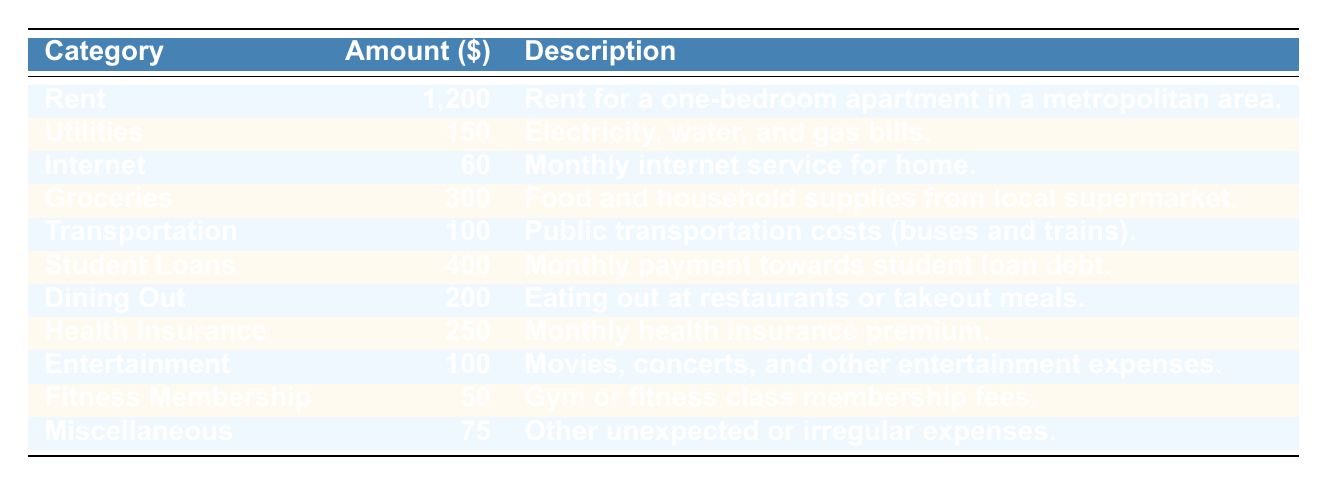What is the highest monthly expense category? Looking at the table, the category with the highest amount is "Rent," which totals 1,200.
Answer: Rent How much do recent graduates spend on utilities each month? The table lists "Utilities" as 150, indicating that is the monthly expense amount.
Answer: 150 What is the total expense on groceries and dining out combined? Adding the amounts for "Groceries" (300) and "Dining Out" (200) gives a total of 300 + 200 = 500.
Answer: 500 Is the amount spent on internet more than the amount spent on transportation? The amount for "Internet" is 60, and for "Transportation," it is 100. Since 60 is less than 100, the answer is no.
Answer: No What is the total monthly expenditure on health-related categories (health insurance and fitness membership)? The health-related categories are "Health Insurance" at 250 and "Fitness Membership" at 50. Adding these gives 250 + 50 = 300 as the total monthly expenditure.
Answer: 300 What percentage of the total monthly expenses is spent on student loans? Total monthly expenses sum up to 1,200 + 150 + 60 + 300 + 100 + 400 + 200 + 250 + 100 + 50 + 75 = 2,685. The amount for "Student Loans" is 400. To find the percentage, we calculate (400 / 2685) * 100, which is approximately 14.89%.
Answer: 14.89% Which two expenses are the least when combined? The two smallest amounts are "Fitness Membership" at 50 and "Miscellaneous" at 75. Adding them together gives 50 + 75 = 125, which is the least combined expense.
Answer: 125 Does the total spending on entertainment exceed that on transportation? The spending on "Entertainment" is 100, and for "Transportation," it is also 100. Since both amounts are equal, the answer is no.
Answer: No What is the average amount spent on rent and health insurance? The amounts for "Rent" is 1,200 and for "Health Insurance," it is 250. To find the average, we sum these values (1,200 + 250 = 1,450) and divide by 2, resulting in 1,450 / 2 = 725.
Answer: 725 